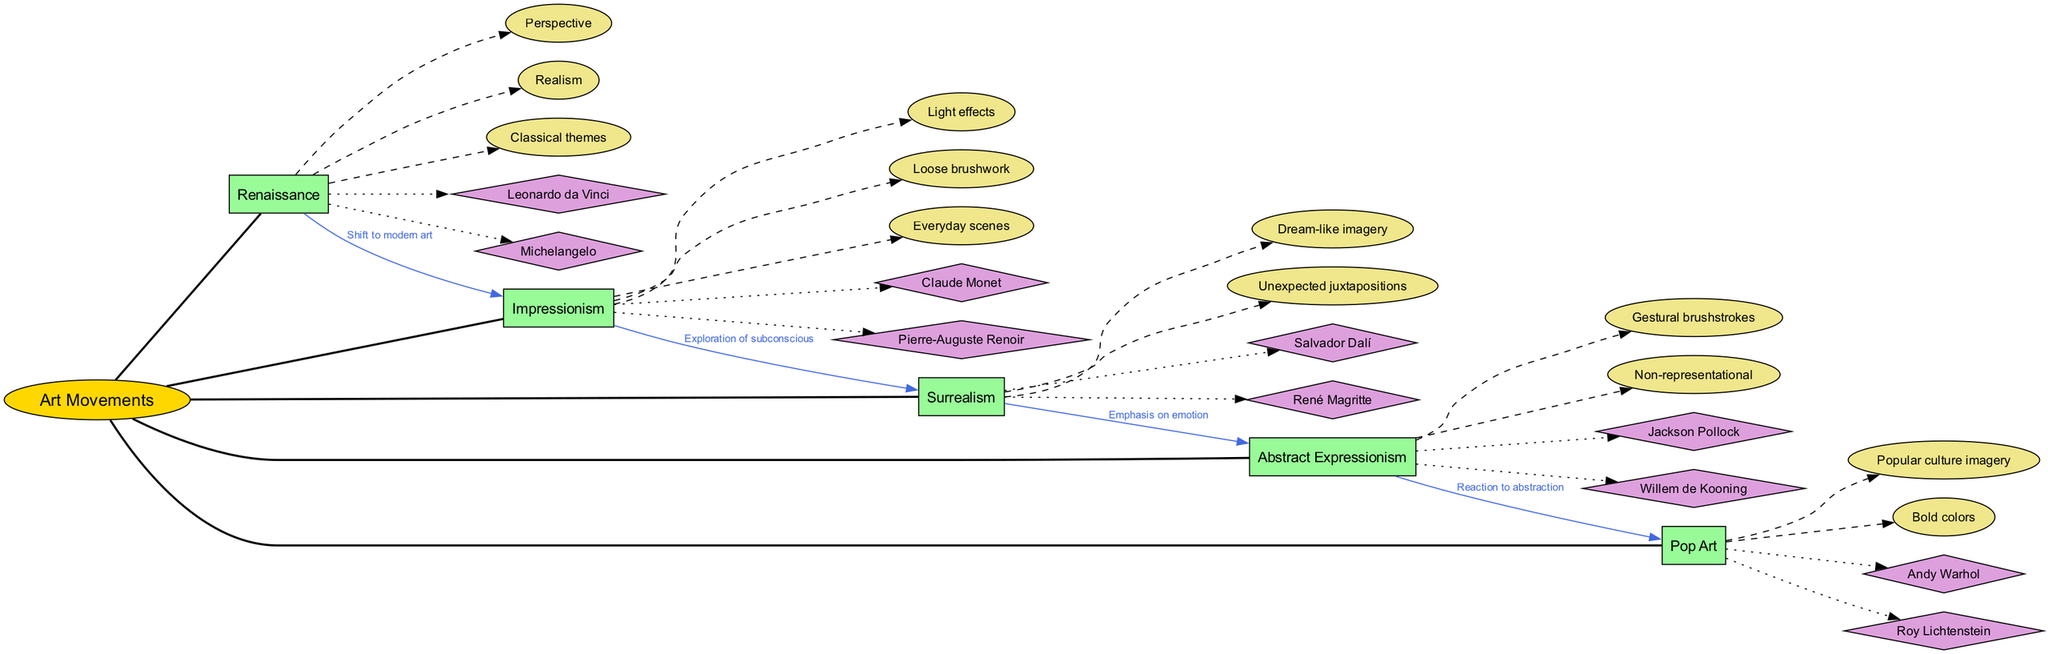What is the central concept represented in the diagram? The diagram's center node is labeled "Art Movements," indicating that this is the main theme or subject being explored.
Answer: Art Movements How many main branches are shown in the diagram? There are five main branches illustrated, each representing a different art movement, such as Renaissance and Impressionism.
Answer: 5 Which art movement is characterized by "Dream-like imagery"? The characteristics "Dream-like imagery" is specifically listed under the Surrealism branch in the diagram.
Answer: Surrealism Who are the key artists associated with Impressionism? The key artists connected to the Impressionism branch are Claude Monet and Pierre-Auguste Renoir, as noted in the diagram.
Answer: Claude Monet, Pierre-Auguste Renoir What connection exists between Abstract Expressionism and Pop Art? The connection labeled "Reaction to abstraction" indicates the relationship from Abstract Expressionism to Pop Art, showing how Pop Art emerged in response to it.
Answer: Reaction to abstraction Which art movement introduced the idea of "Realism"? The characteristic "Realism" is attributed to the Renaissance branch, emphasizing a key aspect of this art movement.
Answer: Renaissance How does Surrealism relate to Impressionism, according to the diagram? The diagram shows the relationship labeled "Exploration of subconscious," indicating that Surrealism evolved from the ideas presented in Impressionism.
Answer: Exploration of subconscious What is one key characteristic of Abstract Expressionism? One main characteristic of Abstract Expressionism mentioned in the diagram is "Non-representational," highlighting its unique approach to art.
Answer: Non-representational Which artist is noted for association with Pop Art? Andy Warhol is highlighted as a key artist under the Pop Art branch in the diagram, emphasizing his significance in this movement.
Answer: Andy Warhol 